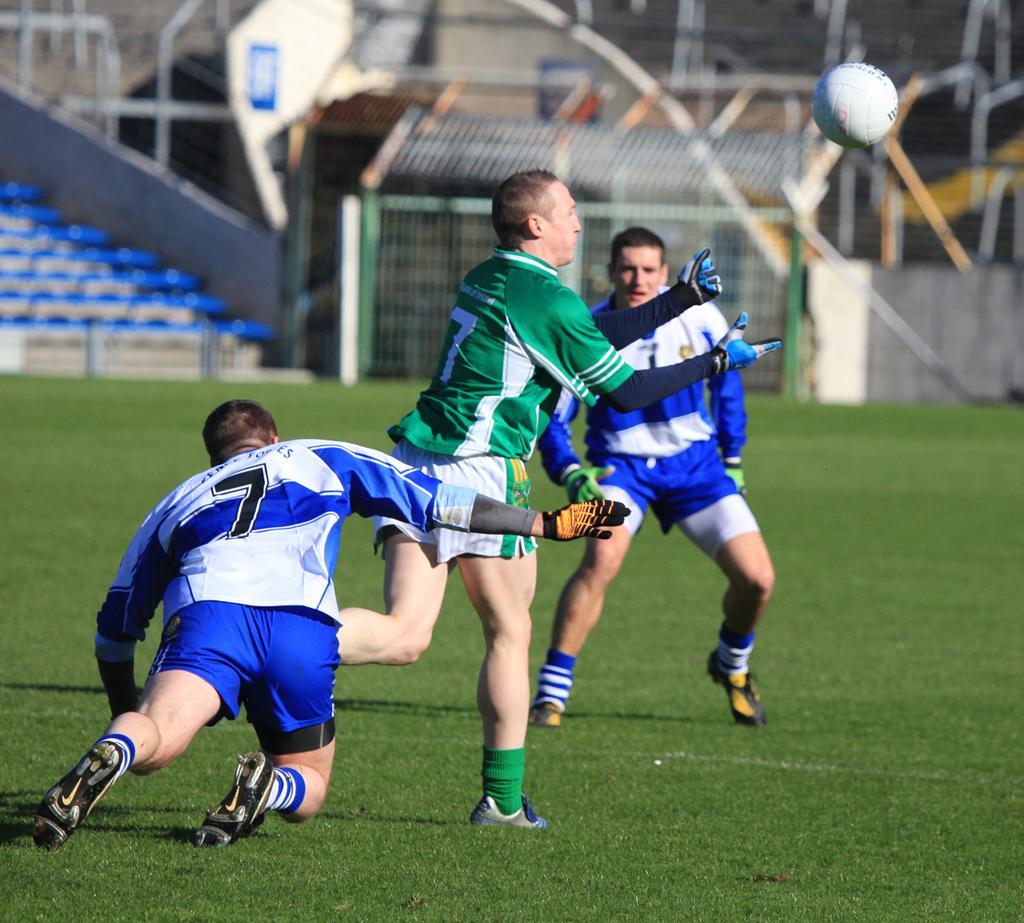Please provide a concise description of this image. This image is taken at the stadium of a football. In this image we can see there are three persons playing football on the ground. 